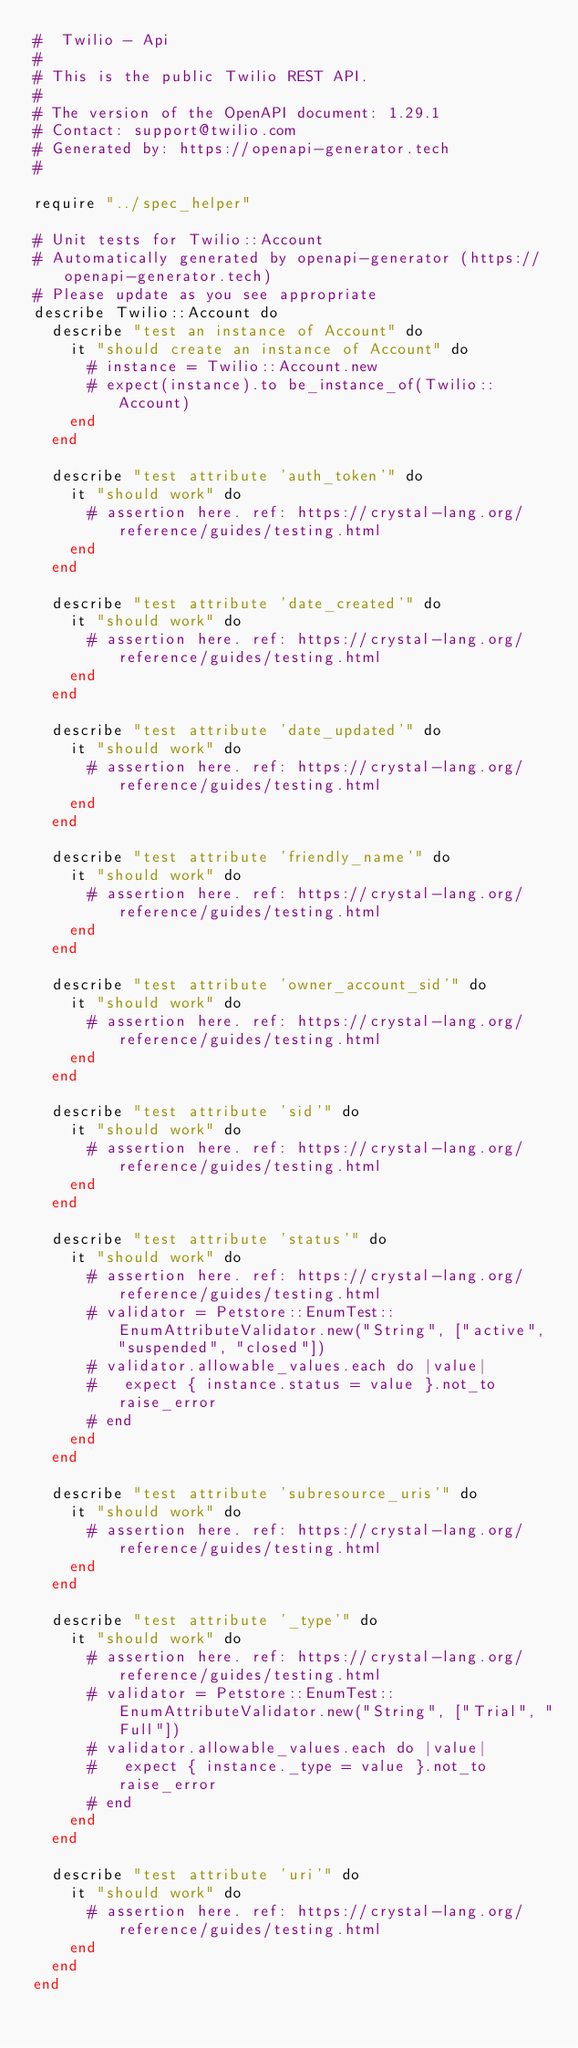<code> <loc_0><loc_0><loc_500><loc_500><_Crystal_>#  Twilio - Api
#
# This is the public Twilio REST API.
#
# The version of the OpenAPI document: 1.29.1
# Contact: support@twilio.com
# Generated by: https://openapi-generator.tech
#

require "../spec_helper"

# Unit tests for Twilio::Account
# Automatically generated by openapi-generator (https://openapi-generator.tech)
# Please update as you see appropriate
describe Twilio::Account do
  describe "test an instance of Account" do
    it "should create an instance of Account" do
      # instance = Twilio::Account.new
      # expect(instance).to be_instance_of(Twilio::Account)
    end
  end

  describe "test attribute 'auth_token'" do
    it "should work" do
      # assertion here. ref: https://crystal-lang.org/reference/guides/testing.html
    end
  end

  describe "test attribute 'date_created'" do
    it "should work" do
      # assertion here. ref: https://crystal-lang.org/reference/guides/testing.html
    end
  end

  describe "test attribute 'date_updated'" do
    it "should work" do
      # assertion here. ref: https://crystal-lang.org/reference/guides/testing.html
    end
  end

  describe "test attribute 'friendly_name'" do
    it "should work" do
      # assertion here. ref: https://crystal-lang.org/reference/guides/testing.html
    end
  end

  describe "test attribute 'owner_account_sid'" do
    it "should work" do
      # assertion here. ref: https://crystal-lang.org/reference/guides/testing.html
    end
  end

  describe "test attribute 'sid'" do
    it "should work" do
      # assertion here. ref: https://crystal-lang.org/reference/guides/testing.html
    end
  end

  describe "test attribute 'status'" do
    it "should work" do
      # assertion here. ref: https://crystal-lang.org/reference/guides/testing.html
      # validator = Petstore::EnumTest::EnumAttributeValidator.new("String", ["active", "suspended", "closed"])
      # validator.allowable_values.each do |value|
      #   expect { instance.status = value }.not_to raise_error
      # end
    end
  end

  describe "test attribute 'subresource_uris'" do
    it "should work" do
      # assertion here. ref: https://crystal-lang.org/reference/guides/testing.html
    end
  end

  describe "test attribute '_type'" do
    it "should work" do
      # assertion here. ref: https://crystal-lang.org/reference/guides/testing.html
      # validator = Petstore::EnumTest::EnumAttributeValidator.new("String", ["Trial", "Full"])
      # validator.allowable_values.each do |value|
      #   expect { instance._type = value }.not_to raise_error
      # end
    end
  end

  describe "test attribute 'uri'" do
    it "should work" do
      # assertion here. ref: https://crystal-lang.org/reference/guides/testing.html
    end
  end
end
</code> 